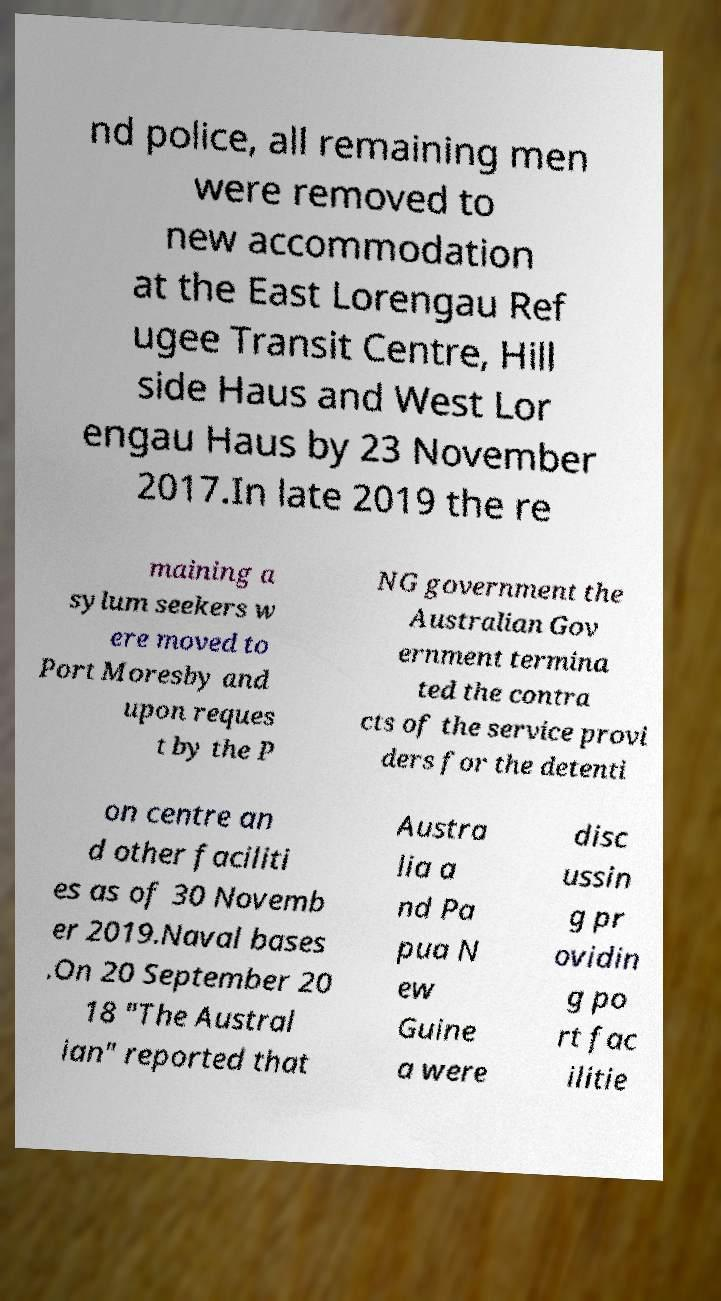Please read and relay the text visible in this image. What does it say? nd police, all remaining men were removed to new accommodation at the East Lorengau Ref ugee Transit Centre, Hill side Haus and West Lor engau Haus by 23 November 2017.In late 2019 the re maining a sylum seekers w ere moved to Port Moresby and upon reques t by the P NG government the Australian Gov ernment termina ted the contra cts of the service provi ders for the detenti on centre an d other faciliti es as of 30 Novemb er 2019.Naval bases .On 20 September 20 18 "The Austral ian" reported that Austra lia a nd Pa pua N ew Guine a were disc ussin g pr ovidin g po rt fac ilitie 